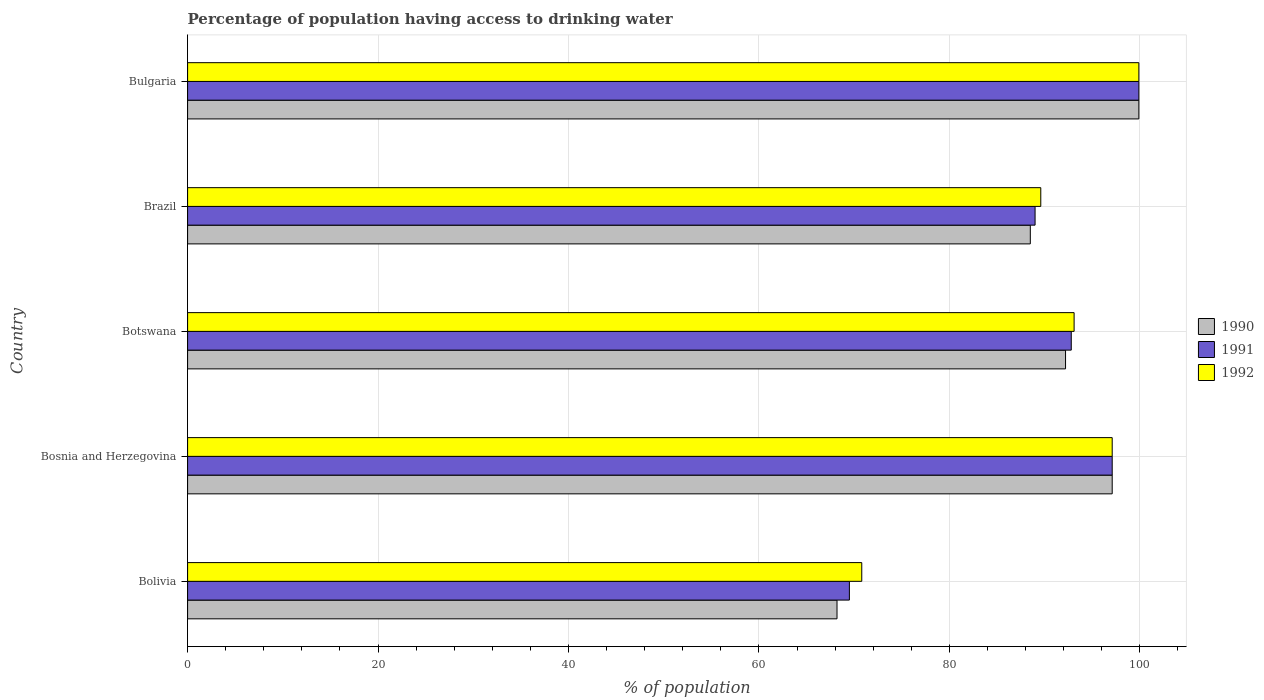How many different coloured bars are there?
Keep it short and to the point. 3. How many groups of bars are there?
Keep it short and to the point. 5. What is the label of the 2nd group of bars from the top?
Provide a succinct answer. Brazil. What is the percentage of population having access to drinking water in 1991 in Brazil?
Provide a short and direct response. 89. Across all countries, what is the maximum percentage of population having access to drinking water in 1991?
Your answer should be very brief. 99.9. Across all countries, what is the minimum percentage of population having access to drinking water in 1990?
Your answer should be very brief. 68.2. In which country was the percentage of population having access to drinking water in 1990 minimum?
Your answer should be very brief. Bolivia. What is the total percentage of population having access to drinking water in 1991 in the graph?
Provide a succinct answer. 448.3. What is the difference between the percentage of population having access to drinking water in 1990 in Bolivia and that in Bosnia and Herzegovina?
Provide a short and direct response. -28.9. What is the difference between the percentage of population having access to drinking water in 1992 in Bolivia and the percentage of population having access to drinking water in 1991 in Bulgaria?
Keep it short and to the point. -29.1. What is the average percentage of population having access to drinking water in 1991 per country?
Keep it short and to the point. 89.66. What is the difference between the percentage of population having access to drinking water in 1992 and percentage of population having access to drinking water in 1991 in Bulgaria?
Provide a succinct answer. 0. What is the ratio of the percentage of population having access to drinking water in 1990 in Brazil to that in Bulgaria?
Give a very brief answer. 0.89. What is the difference between the highest and the second highest percentage of population having access to drinking water in 1992?
Provide a short and direct response. 2.8. What is the difference between the highest and the lowest percentage of population having access to drinking water in 1992?
Provide a succinct answer. 29.1. In how many countries, is the percentage of population having access to drinking water in 1991 greater than the average percentage of population having access to drinking water in 1991 taken over all countries?
Keep it short and to the point. 3. Is the sum of the percentage of population having access to drinking water in 1990 in Bosnia and Herzegovina and Brazil greater than the maximum percentage of population having access to drinking water in 1992 across all countries?
Your answer should be compact. Yes. What does the 3rd bar from the top in Bulgaria represents?
Your answer should be compact. 1990. Is it the case that in every country, the sum of the percentage of population having access to drinking water in 1990 and percentage of population having access to drinking water in 1992 is greater than the percentage of population having access to drinking water in 1991?
Keep it short and to the point. Yes. Are all the bars in the graph horizontal?
Provide a succinct answer. Yes. What is the difference between two consecutive major ticks on the X-axis?
Give a very brief answer. 20. Are the values on the major ticks of X-axis written in scientific E-notation?
Provide a short and direct response. No. Does the graph contain any zero values?
Your answer should be compact. No. What is the title of the graph?
Offer a terse response. Percentage of population having access to drinking water. Does "1991" appear as one of the legend labels in the graph?
Keep it short and to the point. Yes. What is the label or title of the X-axis?
Your answer should be very brief. % of population. What is the label or title of the Y-axis?
Give a very brief answer. Country. What is the % of population of 1990 in Bolivia?
Provide a short and direct response. 68.2. What is the % of population of 1991 in Bolivia?
Your answer should be compact. 69.5. What is the % of population in 1992 in Bolivia?
Offer a very short reply. 70.8. What is the % of population of 1990 in Bosnia and Herzegovina?
Give a very brief answer. 97.1. What is the % of population of 1991 in Bosnia and Herzegovina?
Your response must be concise. 97.1. What is the % of population of 1992 in Bosnia and Herzegovina?
Your answer should be very brief. 97.1. What is the % of population in 1990 in Botswana?
Your response must be concise. 92.2. What is the % of population in 1991 in Botswana?
Keep it short and to the point. 92.8. What is the % of population of 1992 in Botswana?
Ensure brevity in your answer.  93.1. What is the % of population of 1990 in Brazil?
Make the answer very short. 88.5. What is the % of population of 1991 in Brazil?
Your answer should be compact. 89. What is the % of population of 1992 in Brazil?
Your answer should be very brief. 89.6. What is the % of population of 1990 in Bulgaria?
Keep it short and to the point. 99.9. What is the % of population of 1991 in Bulgaria?
Your response must be concise. 99.9. What is the % of population of 1992 in Bulgaria?
Provide a succinct answer. 99.9. Across all countries, what is the maximum % of population in 1990?
Offer a terse response. 99.9. Across all countries, what is the maximum % of population in 1991?
Offer a terse response. 99.9. Across all countries, what is the maximum % of population of 1992?
Provide a succinct answer. 99.9. Across all countries, what is the minimum % of population of 1990?
Keep it short and to the point. 68.2. Across all countries, what is the minimum % of population of 1991?
Your answer should be compact. 69.5. Across all countries, what is the minimum % of population of 1992?
Your answer should be very brief. 70.8. What is the total % of population in 1990 in the graph?
Your response must be concise. 445.9. What is the total % of population of 1991 in the graph?
Your response must be concise. 448.3. What is the total % of population in 1992 in the graph?
Make the answer very short. 450.5. What is the difference between the % of population of 1990 in Bolivia and that in Bosnia and Herzegovina?
Offer a very short reply. -28.9. What is the difference between the % of population in 1991 in Bolivia and that in Bosnia and Herzegovina?
Your answer should be compact. -27.6. What is the difference between the % of population of 1992 in Bolivia and that in Bosnia and Herzegovina?
Give a very brief answer. -26.3. What is the difference between the % of population of 1990 in Bolivia and that in Botswana?
Provide a short and direct response. -24. What is the difference between the % of population in 1991 in Bolivia and that in Botswana?
Your response must be concise. -23.3. What is the difference between the % of population of 1992 in Bolivia and that in Botswana?
Your answer should be compact. -22.3. What is the difference between the % of population of 1990 in Bolivia and that in Brazil?
Give a very brief answer. -20.3. What is the difference between the % of population of 1991 in Bolivia and that in Brazil?
Provide a short and direct response. -19.5. What is the difference between the % of population of 1992 in Bolivia and that in Brazil?
Your answer should be very brief. -18.8. What is the difference between the % of population in 1990 in Bolivia and that in Bulgaria?
Your response must be concise. -31.7. What is the difference between the % of population in 1991 in Bolivia and that in Bulgaria?
Make the answer very short. -30.4. What is the difference between the % of population of 1992 in Bolivia and that in Bulgaria?
Provide a short and direct response. -29.1. What is the difference between the % of population of 1990 in Bosnia and Herzegovina and that in Botswana?
Offer a terse response. 4.9. What is the difference between the % of population of 1992 in Bosnia and Herzegovina and that in Brazil?
Your answer should be compact. 7.5. What is the difference between the % of population of 1990 in Bosnia and Herzegovina and that in Bulgaria?
Ensure brevity in your answer.  -2.8. What is the difference between the % of population of 1992 in Bosnia and Herzegovina and that in Bulgaria?
Your response must be concise. -2.8. What is the difference between the % of population of 1991 in Botswana and that in Brazil?
Your answer should be very brief. 3.8. What is the difference between the % of population in 1990 in Botswana and that in Bulgaria?
Your response must be concise. -7.7. What is the difference between the % of population in 1991 in Botswana and that in Bulgaria?
Ensure brevity in your answer.  -7.1. What is the difference between the % of population of 1992 in Brazil and that in Bulgaria?
Provide a succinct answer. -10.3. What is the difference between the % of population of 1990 in Bolivia and the % of population of 1991 in Bosnia and Herzegovina?
Ensure brevity in your answer.  -28.9. What is the difference between the % of population of 1990 in Bolivia and the % of population of 1992 in Bosnia and Herzegovina?
Provide a succinct answer. -28.9. What is the difference between the % of population of 1991 in Bolivia and the % of population of 1992 in Bosnia and Herzegovina?
Your answer should be compact. -27.6. What is the difference between the % of population in 1990 in Bolivia and the % of population in 1991 in Botswana?
Keep it short and to the point. -24.6. What is the difference between the % of population of 1990 in Bolivia and the % of population of 1992 in Botswana?
Give a very brief answer. -24.9. What is the difference between the % of population of 1991 in Bolivia and the % of population of 1992 in Botswana?
Provide a short and direct response. -23.6. What is the difference between the % of population of 1990 in Bolivia and the % of population of 1991 in Brazil?
Provide a succinct answer. -20.8. What is the difference between the % of population in 1990 in Bolivia and the % of population in 1992 in Brazil?
Offer a very short reply. -21.4. What is the difference between the % of population in 1991 in Bolivia and the % of population in 1992 in Brazil?
Give a very brief answer. -20.1. What is the difference between the % of population of 1990 in Bolivia and the % of population of 1991 in Bulgaria?
Provide a succinct answer. -31.7. What is the difference between the % of population in 1990 in Bolivia and the % of population in 1992 in Bulgaria?
Give a very brief answer. -31.7. What is the difference between the % of population in 1991 in Bolivia and the % of population in 1992 in Bulgaria?
Your answer should be very brief. -30.4. What is the difference between the % of population in 1990 in Bosnia and Herzegovina and the % of population in 1991 in Botswana?
Offer a terse response. 4.3. What is the difference between the % of population of 1990 in Bosnia and Herzegovina and the % of population of 1992 in Botswana?
Your answer should be very brief. 4. What is the difference between the % of population in 1990 in Bosnia and Herzegovina and the % of population in 1991 in Bulgaria?
Ensure brevity in your answer.  -2.8. What is the difference between the % of population in 1990 in Botswana and the % of population in 1992 in Bulgaria?
Give a very brief answer. -7.7. What is the difference between the % of population of 1990 in Brazil and the % of population of 1992 in Bulgaria?
Your answer should be compact. -11.4. What is the difference between the % of population of 1991 in Brazil and the % of population of 1992 in Bulgaria?
Offer a very short reply. -10.9. What is the average % of population of 1990 per country?
Provide a succinct answer. 89.18. What is the average % of population in 1991 per country?
Offer a terse response. 89.66. What is the average % of population in 1992 per country?
Make the answer very short. 90.1. What is the difference between the % of population in 1990 and % of population in 1991 in Bolivia?
Keep it short and to the point. -1.3. What is the difference between the % of population in 1991 and % of population in 1992 in Bolivia?
Your answer should be compact. -1.3. What is the difference between the % of population of 1990 and % of population of 1992 in Bosnia and Herzegovina?
Provide a succinct answer. 0. What is the difference between the % of population in 1991 and % of population in 1992 in Bosnia and Herzegovina?
Offer a terse response. 0. What is the difference between the % of population in 1990 and % of population in 1992 in Botswana?
Give a very brief answer. -0.9. What is the difference between the % of population of 1990 and % of population of 1991 in Brazil?
Make the answer very short. -0.5. What is the difference between the % of population in 1990 and % of population in 1992 in Brazil?
Make the answer very short. -1.1. What is the difference between the % of population of 1991 and % of population of 1992 in Bulgaria?
Offer a very short reply. 0. What is the ratio of the % of population in 1990 in Bolivia to that in Bosnia and Herzegovina?
Offer a very short reply. 0.7. What is the ratio of the % of population of 1991 in Bolivia to that in Bosnia and Herzegovina?
Offer a terse response. 0.72. What is the ratio of the % of population of 1992 in Bolivia to that in Bosnia and Herzegovina?
Provide a succinct answer. 0.73. What is the ratio of the % of population in 1990 in Bolivia to that in Botswana?
Offer a terse response. 0.74. What is the ratio of the % of population in 1991 in Bolivia to that in Botswana?
Keep it short and to the point. 0.75. What is the ratio of the % of population in 1992 in Bolivia to that in Botswana?
Make the answer very short. 0.76. What is the ratio of the % of population of 1990 in Bolivia to that in Brazil?
Your answer should be compact. 0.77. What is the ratio of the % of population of 1991 in Bolivia to that in Brazil?
Offer a very short reply. 0.78. What is the ratio of the % of population in 1992 in Bolivia to that in Brazil?
Ensure brevity in your answer.  0.79. What is the ratio of the % of population of 1990 in Bolivia to that in Bulgaria?
Ensure brevity in your answer.  0.68. What is the ratio of the % of population in 1991 in Bolivia to that in Bulgaria?
Make the answer very short. 0.7. What is the ratio of the % of population in 1992 in Bolivia to that in Bulgaria?
Your answer should be compact. 0.71. What is the ratio of the % of population of 1990 in Bosnia and Herzegovina to that in Botswana?
Offer a terse response. 1.05. What is the ratio of the % of population in 1991 in Bosnia and Herzegovina to that in Botswana?
Provide a succinct answer. 1.05. What is the ratio of the % of population in 1992 in Bosnia and Herzegovina to that in Botswana?
Ensure brevity in your answer.  1.04. What is the ratio of the % of population in 1990 in Bosnia and Herzegovina to that in Brazil?
Provide a short and direct response. 1.1. What is the ratio of the % of population of 1991 in Bosnia and Herzegovina to that in Brazil?
Provide a short and direct response. 1.09. What is the ratio of the % of population of 1992 in Bosnia and Herzegovina to that in Brazil?
Your answer should be very brief. 1.08. What is the ratio of the % of population in 1990 in Bosnia and Herzegovina to that in Bulgaria?
Your response must be concise. 0.97. What is the ratio of the % of population in 1992 in Bosnia and Herzegovina to that in Bulgaria?
Make the answer very short. 0.97. What is the ratio of the % of population of 1990 in Botswana to that in Brazil?
Your answer should be very brief. 1.04. What is the ratio of the % of population in 1991 in Botswana to that in Brazil?
Make the answer very short. 1.04. What is the ratio of the % of population of 1992 in Botswana to that in Brazil?
Offer a terse response. 1.04. What is the ratio of the % of population of 1990 in Botswana to that in Bulgaria?
Make the answer very short. 0.92. What is the ratio of the % of population in 1991 in Botswana to that in Bulgaria?
Give a very brief answer. 0.93. What is the ratio of the % of population in 1992 in Botswana to that in Bulgaria?
Offer a very short reply. 0.93. What is the ratio of the % of population in 1990 in Brazil to that in Bulgaria?
Your answer should be compact. 0.89. What is the ratio of the % of population in 1991 in Brazil to that in Bulgaria?
Ensure brevity in your answer.  0.89. What is the ratio of the % of population in 1992 in Brazil to that in Bulgaria?
Keep it short and to the point. 0.9. What is the difference between the highest and the second highest % of population of 1991?
Make the answer very short. 2.8. What is the difference between the highest and the second highest % of population in 1992?
Provide a succinct answer. 2.8. What is the difference between the highest and the lowest % of population of 1990?
Your answer should be very brief. 31.7. What is the difference between the highest and the lowest % of population of 1991?
Keep it short and to the point. 30.4. What is the difference between the highest and the lowest % of population of 1992?
Offer a terse response. 29.1. 